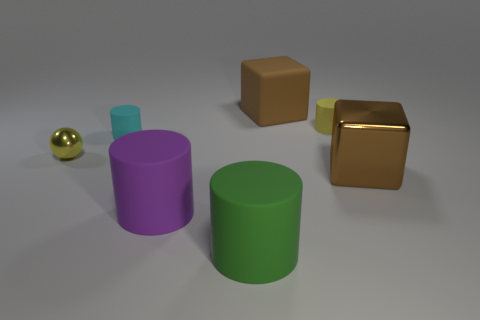Can you describe the lighting in the scene? The scene is softly lit from above, casting gentle shadows and giving the objects a three-dimensional appearance, with no harsh reflections or overexposed areas. 